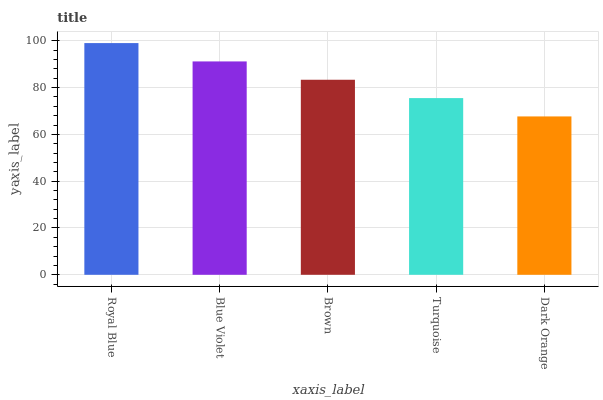Is Blue Violet the minimum?
Answer yes or no. No. Is Blue Violet the maximum?
Answer yes or no. No. Is Royal Blue greater than Blue Violet?
Answer yes or no. Yes. Is Blue Violet less than Royal Blue?
Answer yes or no. Yes. Is Blue Violet greater than Royal Blue?
Answer yes or no. No. Is Royal Blue less than Blue Violet?
Answer yes or no. No. Is Brown the high median?
Answer yes or no. Yes. Is Brown the low median?
Answer yes or no. Yes. Is Royal Blue the high median?
Answer yes or no. No. Is Royal Blue the low median?
Answer yes or no. No. 